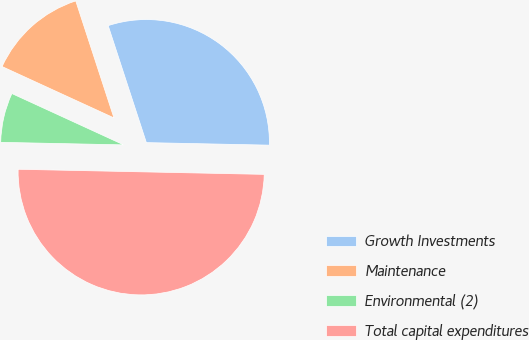<chart> <loc_0><loc_0><loc_500><loc_500><pie_chart><fcel>Growth Investments<fcel>Maintenance<fcel>Environmental (2)<fcel>Total capital expenditures<nl><fcel>30.35%<fcel>13.13%<fcel>6.52%<fcel>50.0%<nl></chart> 